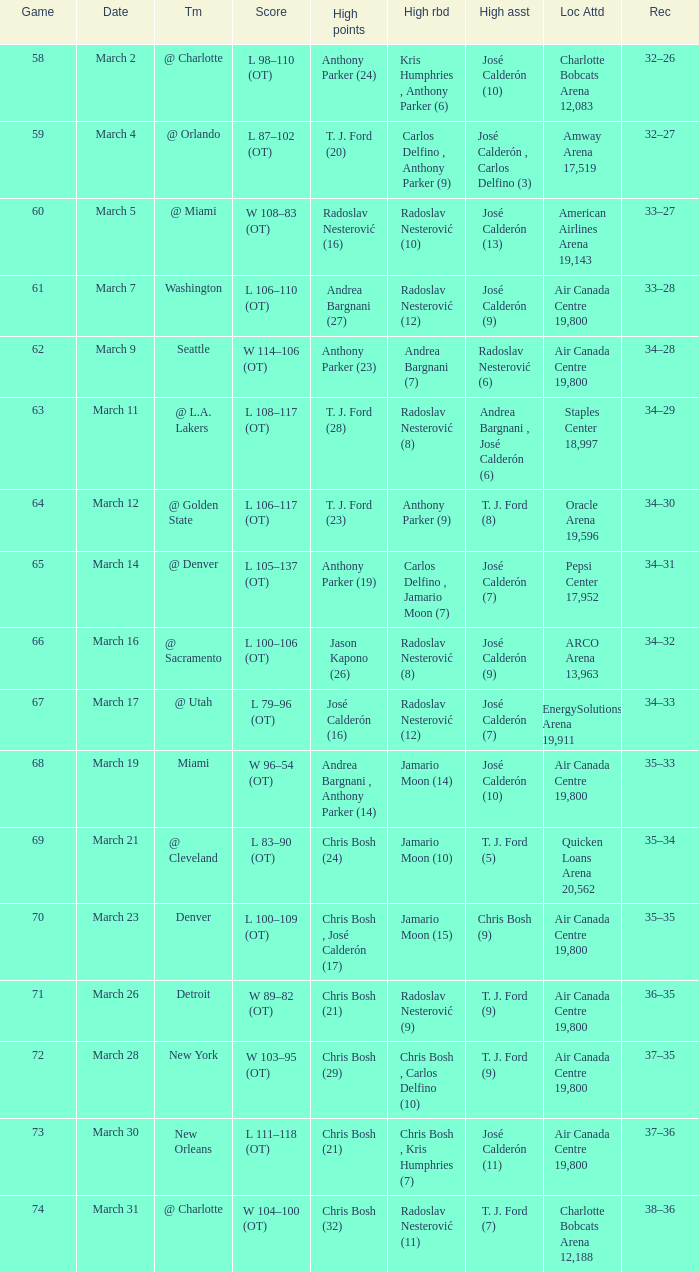How many attended the game on march 16 after over 64 games? ARCO Arena 13,963. 